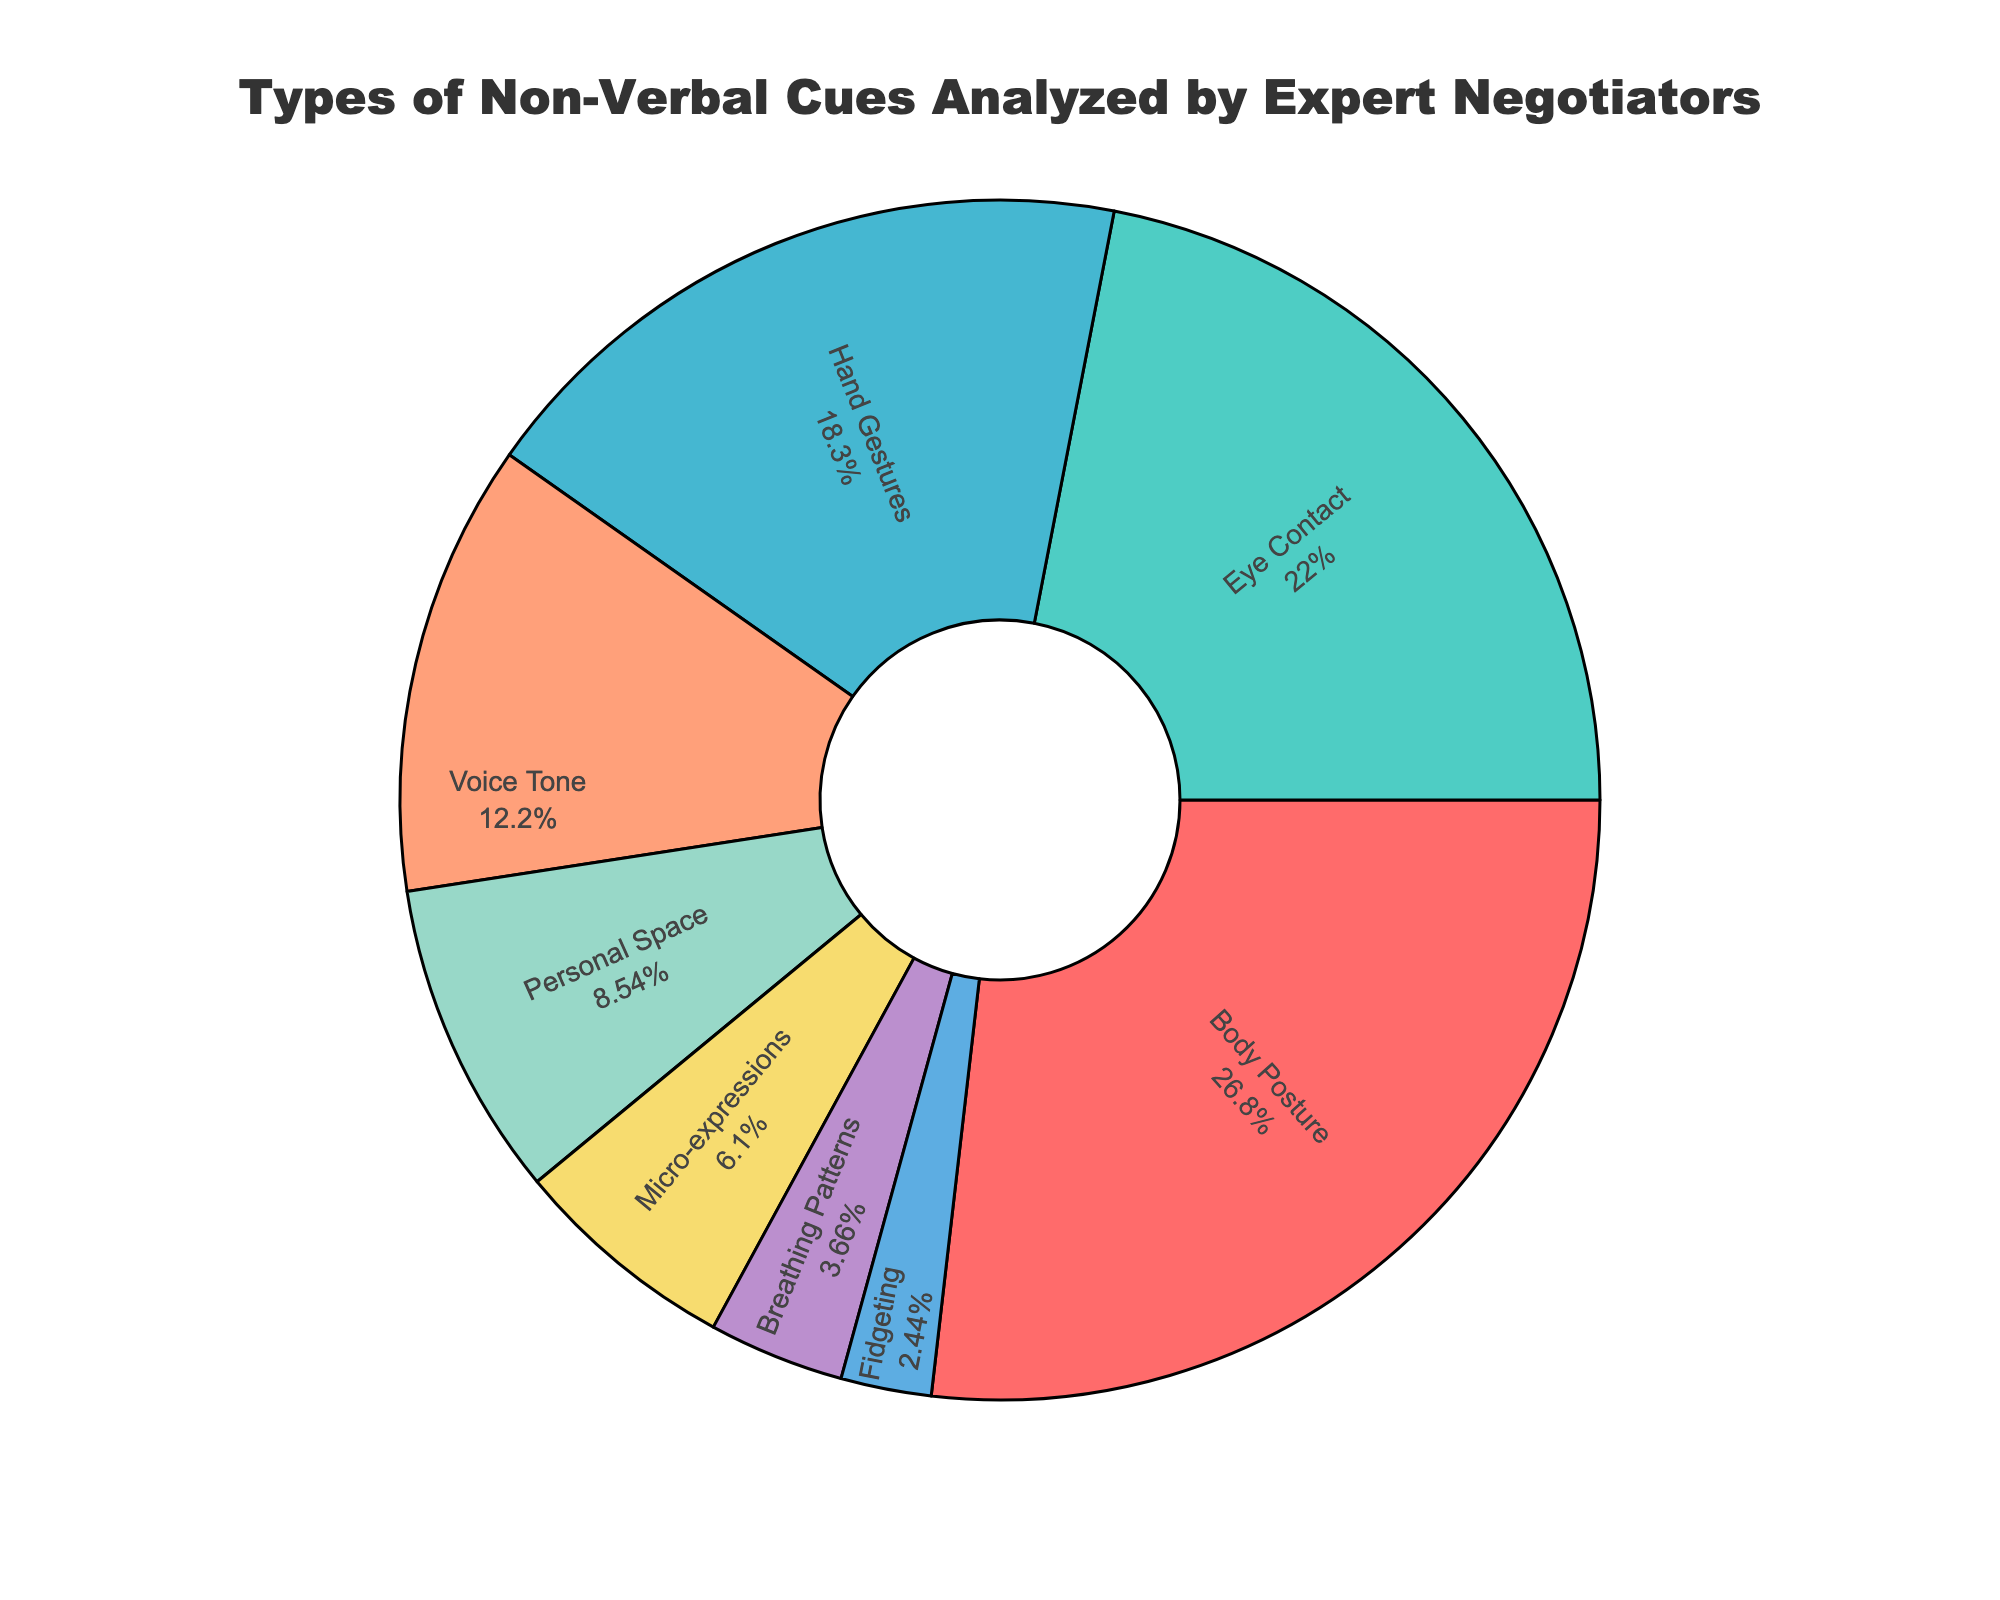What percentage of non-verbal cues are related to facial expressions? The figure shows that facial expressions make up a portion of the pie chart. By looking at the chart, we see that facial expressions account for 28% of the total non-verbal cues.
Answer: 28% Which type of non-verbal cue is analyzed the least by expert negotiators? Examining the pie chart, we see that the smallest slice corresponds to "Fidgeting." This segment is only 2% of the total non-verbal cues analyzed.
Answer: Fidgeting How much more prevalent are facial expressions compared to hand gestures? According to the pie chart, facial expressions make up 28%, while hand gestures make up 15%. Subtracting the percentage of hand gestures from that of facial expressions gives us 28% - 15% = 13%.
Answer: 13% If we combine the categories of "Body Posture" and "Eye Contact," what percentage of non-verbal cues do they together represent? Adding the percentages for body posture (22%) and eye contact (18%) results in a combined total of 22% + 18% = 40%.
Answer: 40% Which non-verbal cue categories together make up exactly half of the total analyzed cues? Adding up the percentages of facial expressions (28%) and body posture (22%) results in 28% + 22% = 50%, exactly half of the total non-verbal cues.
Answer: Facial Expressions and Body Posture Which non-verbal cue is analyzed almost as much as voice tone? Comparing the segment sizes, the slice for hand gestures (15%) is close to the size for voice tone (10%).
Answer: Hand Gestures Is the sum of non-verbal cues related to personal space and micro-expressions greater than the sum related to breathing patterns and fidgeting? Adding up the percentages: Personal Space (7%) + Micro-expressions (5%) = 12%, and Breathing Patterns (3%) + Fidgeting (2%) = 5%; thus, 12% is greater than 5%.
Answer: Yes Which segment appears to be the third-largest in terms of percentage? Observing the pie chart, the third-largest segment after facial expressions and body posture is eye contact, which makes up 18% of the total non-verbal cues.
Answer: Eye Contact What is the combined percentage for cues associated with micro-expressions, breathing patterns, and fidgeting? Adding the percentages: Micro-expressions (5%) + Breathing Patterns (3%) + Fidgeting (2%) = 5% + 3% + 2% = 10%.
Answer: 10% 